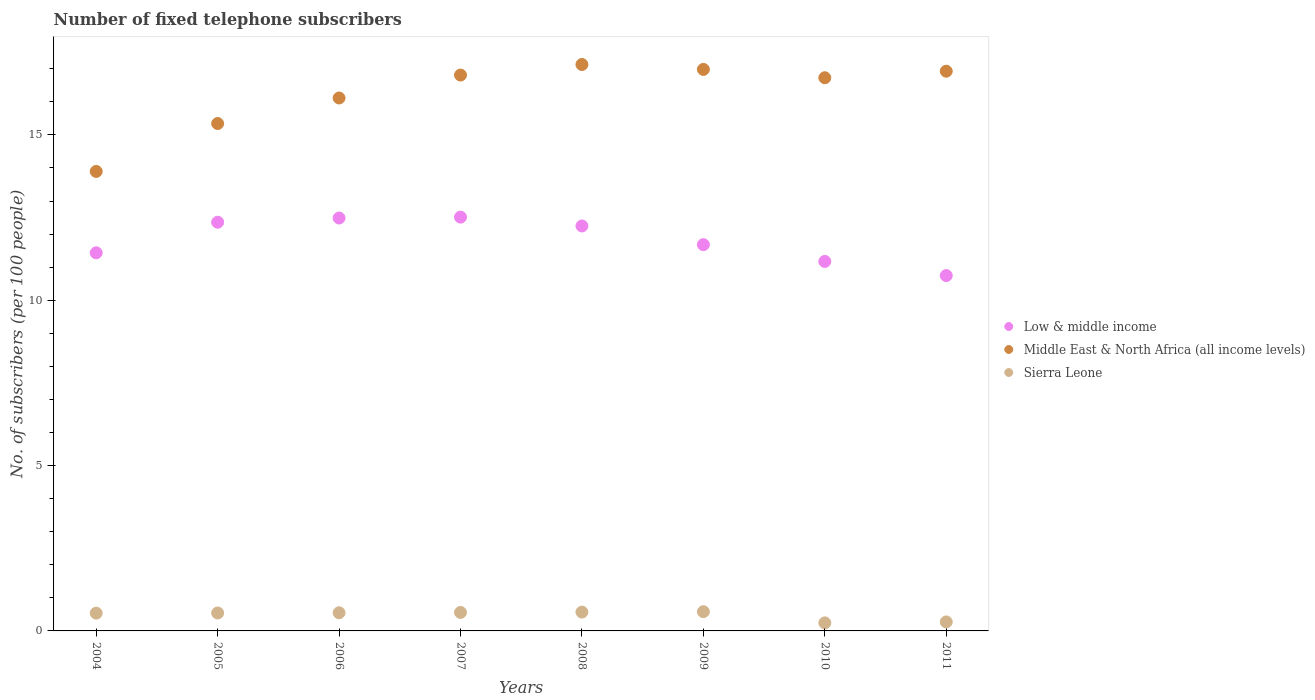How many different coloured dotlines are there?
Your answer should be compact. 3. What is the number of fixed telephone subscribers in Low & middle income in 2007?
Ensure brevity in your answer.  12.51. Across all years, what is the maximum number of fixed telephone subscribers in Low & middle income?
Offer a very short reply. 12.51. Across all years, what is the minimum number of fixed telephone subscribers in Middle East & North Africa (all income levels)?
Offer a terse response. 13.9. What is the total number of fixed telephone subscribers in Middle East & North Africa (all income levels) in the graph?
Offer a very short reply. 129.94. What is the difference between the number of fixed telephone subscribers in Low & middle income in 2008 and that in 2009?
Offer a terse response. 0.57. What is the difference between the number of fixed telephone subscribers in Low & middle income in 2010 and the number of fixed telephone subscribers in Middle East & North Africa (all income levels) in 2007?
Your answer should be very brief. -5.64. What is the average number of fixed telephone subscribers in Middle East & North Africa (all income levels) per year?
Make the answer very short. 16.24. In the year 2009, what is the difference between the number of fixed telephone subscribers in Middle East & North Africa (all income levels) and number of fixed telephone subscribers in Low & middle income?
Keep it short and to the point. 5.3. What is the ratio of the number of fixed telephone subscribers in Low & middle income in 2005 to that in 2009?
Offer a very short reply. 1.06. Is the difference between the number of fixed telephone subscribers in Middle East & North Africa (all income levels) in 2005 and 2011 greater than the difference between the number of fixed telephone subscribers in Low & middle income in 2005 and 2011?
Your response must be concise. No. What is the difference between the highest and the second highest number of fixed telephone subscribers in Sierra Leone?
Keep it short and to the point. 0.01. What is the difference between the highest and the lowest number of fixed telephone subscribers in Low & middle income?
Your answer should be very brief. 1.77. Is it the case that in every year, the sum of the number of fixed telephone subscribers in Low & middle income and number of fixed telephone subscribers in Sierra Leone  is greater than the number of fixed telephone subscribers in Middle East & North Africa (all income levels)?
Make the answer very short. No. Does the number of fixed telephone subscribers in Low & middle income monotonically increase over the years?
Provide a succinct answer. No. Is the number of fixed telephone subscribers in Sierra Leone strictly greater than the number of fixed telephone subscribers in Low & middle income over the years?
Ensure brevity in your answer.  No. How many dotlines are there?
Offer a terse response. 3. What is the difference between two consecutive major ticks on the Y-axis?
Your answer should be compact. 5. Does the graph contain any zero values?
Make the answer very short. No. How are the legend labels stacked?
Make the answer very short. Vertical. What is the title of the graph?
Offer a very short reply. Number of fixed telephone subscribers. What is the label or title of the Y-axis?
Offer a very short reply. No. of subscribers (per 100 people). What is the No. of subscribers (per 100 people) in Low & middle income in 2004?
Offer a very short reply. 11.44. What is the No. of subscribers (per 100 people) of Middle East & North Africa (all income levels) in 2004?
Make the answer very short. 13.9. What is the No. of subscribers (per 100 people) in Sierra Leone in 2004?
Make the answer very short. 0.54. What is the No. of subscribers (per 100 people) of Low & middle income in 2005?
Make the answer very short. 12.36. What is the No. of subscribers (per 100 people) in Middle East & North Africa (all income levels) in 2005?
Provide a succinct answer. 15.34. What is the No. of subscribers (per 100 people) in Sierra Leone in 2005?
Your response must be concise. 0.54. What is the No. of subscribers (per 100 people) of Low & middle income in 2006?
Your answer should be compact. 12.49. What is the No. of subscribers (per 100 people) in Middle East & North Africa (all income levels) in 2006?
Provide a succinct answer. 16.12. What is the No. of subscribers (per 100 people) in Sierra Leone in 2006?
Offer a very short reply. 0.55. What is the No. of subscribers (per 100 people) in Low & middle income in 2007?
Provide a short and direct response. 12.51. What is the No. of subscribers (per 100 people) of Middle East & North Africa (all income levels) in 2007?
Your response must be concise. 16.81. What is the No. of subscribers (per 100 people) of Sierra Leone in 2007?
Make the answer very short. 0.56. What is the No. of subscribers (per 100 people) in Low & middle income in 2008?
Ensure brevity in your answer.  12.25. What is the No. of subscribers (per 100 people) in Middle East & North Africa (all income levels) in 2008?
Give a very brief answer. 17.13. What is the No. of subscribers (per 100 people) in Sierra Leone in 2008?
Your answer should be compact. 0.57. What is the No. of subscribers (per 100 people) in Low & middle income in 2009?
Keep it short and to the point. 11.68. What is the No. of subscribers (per 100 people) in Middle East & North Africa (all income levels) in 2009?
Provide a short and direct response. 16.98. What is the No. of subscribers (per 100 people) in Sierra Leone in 2009?
Provide a short and direct response. 0.58. What is the No. of subscribers (per 100 people) in Low & middle income in 2010?
Provide a short and direct response. 11.17. What is the No. of subscribers (per 100 people) of Middle East & North Africa (all income levels) in 2010?
Offer a very short reply. 16.73. What is the No. of subscribers (per 100 people) in Sierra Leone in 2010?
Your answer should be compact. 0.24. What is the No. of subscribers (per 100 people) in Low & middle income in 2011?
Your response must be concise. 10.75. What is the No. of subscribers (per 100 people) of Middle East & North Africa (all income levels) in 2011?
Offer a very short reply. 16.93. What is the No. of subscribers (per 100 people) of Sierra Leone in 2011?
Offer a very short reply. 0.27. Across all years, what is the maximum No. of subscribers (per 100 people) in Low & middle income?
Provide a short and direct response. 12.51. Across all years, what is the maximum No. of subscribers (per 100 people) in Middle East & North Africa (all income levels)?
Offer a terse response. 17.13. Across all years, what is the maximum No. of subscribers (per 100 people) of Sierra Leone?
Offer a terse response. 0.58. Across all years, what is the minimum No. of subscribers (per 100 people) of Low & middle income?
Keep it short and to the point. 10.75. Across all years, what is the minimum No. of subscribers (per 100 people) of Middle East & North Africa (all income levels)?
Your response must be concise. 13.9. Across all years, what is the minimum No. of subscribers (per 100 people) in Sierra Leone?
Ensure brevity in your answer.  0.24. What is the total No. of subscribers (per 100 people) in Low & middle income in the graph?
Provide a short and direct response. 94.64. What is the total No. of subscribers (per 100 people) of Middle East & North Africa (all income levels) in the graph?
Ensure brevity in your answer.  129.94. What is the total No. of subscribers (per 100 people) in Sierra Leone in the graph?
Offer a terse response. 3.86. What is the difference between the No. of subscribers (per 100 people) of Low & middle income in 2004 and that in 2005?
Your answer should be compact. -0.92. What is the difference between the No. of subscribers (per 100 people) of Middle East & North Africa (all income levels) in 2004 and that in 2005?
Ensure brevity in your answer.  -1.45. What is the difference between the No. of subscribers (per 100 people) in Sierra Leone in 2004 and that in 2005?
Your response must be concise. -0.01. What is the difference between the No. of subscribers (per 100 people) in Low & middle income in 2004 and that in 2006?
Your answer should be very brief. -1.05. What is the difference between the No. of subscribers (per 100 people) of Middle East & North Africa (all income levels) in 2004 and that in 2006?
Offer a terse response. -2.22. What is the difference between the No. of subscribers (per 100 people) of Sierra Leone in 2004 and that in 2006?
Your answer should be very brief. -0.01. What is the difference between the No. of subscribers (per 100 people) in Low & middle income in 2004 and that in 2007?
Offer a terse response. -1.08. What is the difference between the No. of subscribers (per 100 people) in Middle East & North Africa (all income levels) in 2004 and that in 2007?
Make the answer very short. -2.91. What is the difference between the No. of subscribers (per 100 people) of Sierra Leone in 2004 and that in 2007?
Make the answer very short. -0.02. What is the difference between the No. of subscribers (per 100 people) of Low & middle income in 2004 and that in 2008?
Ensure brevity in your answer.  -0.81. What is the difference between the No. of subscribers (per 100 people) in Middle East & North Africa (all income levels) in 2004 and that in 2008?
Your response must be concise. -3.23. What is the difference between the No. of subscribers (per 100 people) in Sierra Leone in 2004 and that in 2008?
Offer a terse response. -0.03. What is the difference between the No. of subscribers (per 100 people) in Low & middle income in 2004 and that in 2009?
Your answer should be very brief. -0.25. What is the difference between the No. of subscribers (per 100 people) in Middle East & North Africa (all income levels) in 2004 and that in 2009?
Provide a succinct answer. -3.09. What is the difference between the No. of subscribers (per 100 people) in Sierra Leone in 2004 and that in 2009?
Keep it short and to the point. -0.04. What is the difference between the No. of subscribers (per 100 people) in Low & middle income in 2004 and that in 2010?
Your answer should be very brief. 0.26. What is the difference between the No. of subscribers (per 100 people) of Middle East & North Africa (all income levels) in 2004 and that in 2010?
Provide a succinct answer. -2.83. What is the difference between the No. of subscribers (per 100 people) of Sierra Leone in 2004 and that in 2010?
Your answer should be very brief. 0.29. What is the difference between the No. of subscribers (per 100 people) in Low & middle income in 2004 and that in 2011?
Your answer should be compact. 0.69. What is the difference between the No. of subscribers (per 100 people) in Middle East & North Africa (all income levels) in 2004 and that in 2011?
Provide a succinct answer. -3.03. What is the difference between the No. of subscribers (per 100 people) of Sierra Leone in 2004 and that in 2011?
Provide a succinct answer. 0.26. What is the difference between the No. of subscribers (per 100 people) in Low & middle income in 2005 and that in 2006?
Offer a terse response. -0.13. What is the difference between the No. of subscribers (per 100 people) in Middle East & North Africa (all income levels) in 2005 and that in 2006?
Provide a short and direct response. -0.77. What is the difference between the No. of subscribers (per 100 people) in Sierra Leone in 2005 and that in 2006?
Offer a very short reply. -0.01. What is the difference between the No. of subscribers (per 100 people) in Low & middle income in 2005 and that in 2007?
Provide a succinct answer. -0.15. What is the difference between the No. of subscribers (per 100 people) in Middle East & North Africa (all income levels) in 2005 and that in 2007?
Your answer should be very brief. -1.47. What is the difference between the No. of subscribers (per 100 people) in Sierra Leone in 2005 and that in 2007?
Provide a succinct answer. -0.02. What is the difference between the No. of subscribers (per 100 people) of Low & middle income in 2005 and that in 2008?
Provide a succinct answer. 0.11. What is the difference between the No. of subscribers (per 100 people) in Middle East & North Africa (all income levels) in 2005 and that in 2008?
Make the answer very short. -1.79. What is the difference between the No. of subscribers (per 100 people) of Sierra Leone in 2005 and that in 2008?
Your answer should be very brief. -0.03. What is the difference between the No. of subscribers (per 100 people) in Low & middle income in 2005 and that in 2009?
Your answer should be very brief. 0.68. What is the difference between the No. of subscribers (per 100 people) of Middle East & North Africa (all income levels) in 2005 and that in 2009?
Give a very brief answer. -1.64. What is the difference between the No. of subscribers (per 100 people) in Sierra Leone in 2005 and that in 2009?
Give a very brief answer. -0.04. What is the difference between the No. of subscribers (per 100 people) in Low & middle income in 2005 and that in 2010?
Offer a terse response. 1.19. What is the difference between the No. of subscribers (per 100 people) in Middle East & North Africa (all income levels) in 2005 and that in 2010?
Your answer should be very brief. -1.38. What is the difference between the No. of subscribers (per 100 people) of Sierra Leone in 2005 and that in 2010?
Offer a very short reply. 0.3. What is the difference between the No. of subscribers (per 100 people) in Low & middle income in 2005 and that in 2011?
Keep it short and to the point. 1.61. What is the difference between the No. of subscribers (per 100 people) in Middle East & North Africa (all income levels) in 2005 and that in 2011?
Keep it short and to the point. -1.58. What is the difference between the No. of subscribers (per 100 people) of Sierra Leone in 2005 and that in 2011?
Your response must be concise. 0.27. What is the difference between the No. of subscribers (per 100 people) in Low & middle income in 2006 and that in 2007?
Give a very brief answer. -0.03. What is the difference between the No. of subscribers (per 100 people) of Middle East & North Africa (all income levels) in 2006 and that in 2007?
Ensure brevity in your answer.  -0.69. What is the difference between the No. of subscribers (per 100 people) of Sierra Leone in 2006 and that in 2007?
Keep it short and to the point. -0.01. What is the difference between the No. of subscribers (per 100 people) of Low & middle income in 2006 and that in 2008?
Ensure brevity in your answer.  0.24. What is the difference between the No. of subscribers (per 100 people) in Middle East & North Africa (all income levels) in 2006 and that in 2008?
Your answer should be compact. -1.01. What is the difference between the No. of subscribers (per 100 people) of Sierra Leone in 2006 and that in 2008?
Offer a very short reply. -0.02. What is the difference between the No. of subscribers (per 100 people) in Low & middle income in 2006 and that in 2009?
Give a very brief answer. 0.81. What is the difference between the No. of subscribers (per 100 people) in Middle East & North Africa (all income levels) in 2006 and that in 2009?
Your response must be concise. -0.86. What is the difference between the No. of subscribers (per 100 people) in Sierra Leone in 2006 and that in 2009?
Ensure brevity in your answer.  -0.03. What is the difference between the No. of subscribers (per 100 people) of Low & middle income in 2006 and that in 2010?
Provide a succinct answer. 1.31. What is the difference between the No. of subscribers (per 100 people) of Middle East & North Africa (all income levels) in 2006 and that in 2010?
Your answer should be compact. -0.61. What is the difference between the No. of subscribers (per 100 people) of Sierra Leone in 2006 and that in 2010?
Give a very brief answer. 0.31. What is the difference between the No. of subscribers (per 100 people) in Low & middle income in 2006 and that in 2011?
Your answer should be very brief. 1.74. What is the difference between the No. of subscribers (per 100 people) of Middle East & North Africa (all income levels) in 2006 and that in 2011?
Your answer should be compact. -0.81. What is the difference between the No. of subscribers (per 100 people) in Sierra Leone in 2006 and that in 2011?
Keep it short and to the point. 0.28. What is the difference between the No. of subscribers (per 100 people) in Low & middle income in 2007 and that in 2008?
Ensure brevity in your answer.  0.27. What is the difference between the No. of subscribers (per 100 people) in Middle East & North Africa (all income levels) in 2007 and that in 2008?
Offer a very short reply. -0.32. What is the difference between the No. of subscribers (per 100 people) in Sierra Leone in 2007 and that in 2008?
Ensure brevity in your answer.  -0.01. What is the difference between the No. of subscribers (per 100 people) in Low & middle income in 2007 and that in 2009?
Ensure brevity in your answer.  0.83. What is the difference between the No. of subscribers (per 100 people) in Middle East & North Africa (all income levels) in 2007 and that in 2009?
Keep it short and to the point. -0.17. What is the difference between the No. of subscribers (per 100 people) in Sierra Leone in 2007 and that in 2009?
Your answer should be very brief. -0.02. What is the difference between the No. of subscribers (per 100 people) of Low & middle income in 2007 and that in 2010?
Provide a short and direct response. 1.34. What is the difference between the No. of subscribers (per 100 people) in Middle East & North Africa (all income levels) in 2007 and that in 2010?
Your answer should be compact. 0.08. What is the difference between the No. of subscribers (per 100 people) of Sierra Leone in 2007 and that in 2010?
Offer a very short reply. 0.32. What is the difference between the No. of subscribers (per 100 people) of Low & middle income in 2007 and that in 2011?
Offer a terse response. 1.77. What is the difference between the No. of subscribers (per 100 people) in Middle East & North Africa (all income levels) in 2007 and that in 2011?
Your answer should be very brief. -0.12. What is the difference between the No. of subscribers (per 100 people) of Sierra Leone in 2007 and that in 2011?
Make the answer very short. 0.29. What is the difference between the No. of subscribers (per 100 people) of Low & middle income in 2008 and that in 2009?
Your answer should be compact. 0.57. What is the difference between the No. of subscribers (per 100 people) of Middle East & North Africa (all income levels) in 2008 and that in 2009?
Provide a short and direct response. 0.15. What is the difference between the No. of subscribers (per 100 people) of Sierra Leone in 2008 and that in 2009?
Your response must be concise. -0.01. What is the difference between the No. of subscribers (per 100 people) of Low & middle income in 2008 and that in 2010?
Provide a short and direct response. 1.07. What is the difference between the No. of subscribers (per 100 people) in Middle East & North Africa (all income levels) in 2008 and that in 2010?
Keep it short and to the point. 0.4. What is the difference between the No. of subscribers (per 100 people) in Sierra Leone in 2008 and that in 2010?
Your answer should be very brief. 0.33. What is the difference between the No. of subscribers (per 100 people) of Low & middle income in 2008 and that in 2011?
Provide a succinct answer. 1.5. What is the difference between the No. of subscribers (per 100 people) of Middle East & North Africa (all income levels) in 2008 and that in 2011?
Make the answer very short. 0.2. What is the difference between the No. of subscribers (per 100 people) in Sierra Leone in 2008 and that in 2011?
Provide a succinct answer. 0.3. What is the difference between the No. of subscribers (per 100 people) in Low & middle income in 2009 and that in 2010?
Ensure brevity in your answer.  0.51. What is the difference between the No. of subscribers (per 100 people) in Middle East & North Africa (all income levels) in 2009 and that in 2010?
Your response must be concise. 0.25. What is the difference between the No. of subscribers (per 100 people) in Sierra Leone in 2009 and that in 2010?
Provide a succinct answer. 0.34. What is the difference between the No. of subscribers (per 100 people) of Low & middle income in 2009 and that in 2011?
Your answer should be very brief. 0.93. What is the difference between the No. of subscribers (per 100 people) in Middle East & North Africa (all income levels) in 2009 and that in 2011?
Your answer should be compact. 0.05. What is the difference between the No. of subscribers (per 100 people) of Sierra Leone in 2009 and that in 2011?
Your answer should be very brief. 0.31. What is the difference between the No. of subscribers (per 100 people) of Low & middle income in 2010 and that in 2011?
Your answer should be compact. 0.43. What is the difference between the No. of subscribers (per 100 people) in Middle East & North Africa (all income levels) in 2010 and that in 2011?
Make the answer very short. -0.2. What is the difference between the No. of subscribers (per 100 people) of Sierra Leone in 2010 and that in 2011?
Ensure brevity in your answer.  -0.03. What is the difference between the No. of subscribers (per 100 people) of Low & middle income in 2004 and the No. of subscribers (per 100 people) of Middle East & North Africa (all income levels) in 2005?
Keep it short and to the point. -3.91. What is the difference between the No. of subscribers (per 100 people) of Low & middle income in 2004 and the No. of subscribers (per 100 people) of Sierra Leone in 2005?
Your response must be concise. 10.89. What is the difference between the No. of subscribers (per 100 people) in Middle East & North Africa (all income levels) in 2004 and the No. of subscribers (per 100 people) in Sierra Leone in 2005?
Offer a terse response. 13.35. What is the difference between the No. of subscribers (per 100 people) in Low & middle income in 2004 and the No. of subscribers (per 100 people) in Middle East & North Africa (all income levels) in 2006?
Ensure brevity in your answer.  -4.68. What is the difference between the No. of subscribers (per 100 people) in Low & middle income in 2004 and the No. of subscribers (per 100 people) in Sierra Leone in 2006?
Ensure brevity in your answer.  10.89. What is the difference between the No. of subscribers (per 100 people) in Middle East & North Africa (all income levels) in 2004 and the No. of subscribers (per 100 people) in Sierra Leone in 2006?
Provide a short and direct response. 13.35. What is the difference between the No. of subscribers (per 100 people) of Low & middle income in 2004 and the No. of subscribers (per 100 people) of Middle East & North Africa (all income levels) in 2007?
Offer a very short reply. -5.38. What is the difference between the No. of subscribers (per 100 people) of Low & middle income in 2004 and the No. of subscribers (per 100 people) of Sierra Leone in 2007?
Provide a succinct answer. 10.88. What is the difference between the No. of subscribers (per 100 people) of Middle East & North Africa (all income levels) in 2004 and the No. of subscribers (per 100 people) of Sierra Leone in 2007?
Offer a very short reply. 13.34. What is the difference between the No. of subscribers (per 100 people) of Low & middle income in 2004 and the No. of subscribers (per 100 people) of Middle East & North Africa (all income levels) in 2008?
Keep it short and to the point. -5.69. What is the difference between the No. of subscribers (per 100 people) in Low & middle income in 2004 and the No. of subscribers (per 100 people) in Sierra Leone in 2008?
Make the answer very short. 10.87. What is the difference between the No. of subscribers (per 100 people) of Middle East & North Africa (all income levels) in 2004 and the No. of subscribers (per 100 people) of Sierra Leone in 2008?
Give a very brief answer. 13.33. What is the difference between the No. of subscribers (per 100 people) of Low & middle income in 2004 and the No. of subscribers (per 100 people) of Middle East & North Africa (all income levels) in 2009?
Your answer should be compact. -5.55. What is the difference between the No. of subscribers (per 100 people) of Low & middle income in 2004 and the No. of subscribers (per 100 people) of Sierra Leone in 2009?
Your answer should be compact. 10.85. What is the difference between the No. of subscribers (per 100 people) of Middle East & North Africa (all income levels) in 2004 and the No. of subscribers (per 100 people) of Sierra Leone in 2009?
Offer a very short reply. 13.31. What is the difference between the No. of subscribers (per 100 people) in Low & middle income in 2004 and the No. of subscribers (per 100 people) in Middle East & North Africa (all income levels) in 2010?
Offer a very short reply. -5.29. What is the difference between the No. of subscribers (per 100 people) of Low & middle income in 2004 and the No. of subscribers (per 100 people) of Sierra Leone in 2010?
Keep it short and to the point. 11.19. What is the difference between the No. of subscribers (per 100 people) in Middle East & North Africa (all income levels) in 2004 and the No. of subscribers (per 100 people) in Sierra Leone in 2010?
Keep it short and to the point. 13.65. What is the difference between the No. of subscribers (per 100 people) of Low & middle income in 2004 and the No. of subscribers (per 100 people) of Middle East & North Africa (all income levels) in 2011?
Provide a short and direct response. -5.49. What is the difference between the No. of subscribers (per 100 people) in Low & middle income in 2004 and the No. of subscribers (per 100 people) in Sierra Leone in 2011?
Offer a very short reply. 11.16. What is the difference between the No. of subscribers (per 100 people) of Middle East & North Africa (all income levels) in 2004 and the No. of subscribers (per 100 people) of Sierra Leone in 2011?
Give a very brief answer. 13.62. What is the difference between the No. of subscribers (per 100 people) in Low & middle income in 2005 and the No. of subscribers (per 100 people) in Middle East & North Africa (all income levels) in 2006?
Provide a short and direct response. -3.76. What is the difference between the No. of subscribers (per 100 people) of Low & middle income in 2005 and the No. of subscribers (per 100 people) of Sierra Leone in 2006?
Your answer should be compact. 11.81. What is the difference between the No. of subscribers (per 100 people) in Middle East & North Africa (all income levels) in 2005 and the No. of subscribers (per 100 people) in Sierra Leone in 2006?
Your answer should be very brief. 14.8. What is the difference between the No. of subscribers (per 100 people) of Low & middle income in 2005 and the No. of subscribers (per 100 people) of Middle East & North Africa (all income levels) in 2007?
Your answer should be compact. -4.45. What is the difference between the No. of subscribers (per 100 people) of Low & middle income in 2005 and the No. of subscribers (per 100 people) of Sierra Leone in 2007?
Offer a very short reply. 11.8. What is the difference between the No. of subscribers (per 100 people) of Middle East & North Africa (all income levels) in 2005 and the No. of subscribers (per 100 people) of Sierra Leone in 2007?
Your response must be concise. 14.79. What is the difference between the No. of subscribers (per 100 people) of Low & middle income in 2005 and the No. of subscribers (per 100 people) of Middle East & North Africa (all income levels) in 2008?
Keep it short and to the point. -4.77. What is the difference between the No. of subscribers (per 100 people) in Low & middle income in 2005 and the No. of subscribers (per 100 people) in Sierra Leone in 2008?
Offer a terse response. 11.79. What is the difference between the No. of subscribers (per 100 people) in Middle East & North Africa (all income levels) in 2005 and the No. of subscribers (per 100 people) in Sierra Leone in 2008?
Offer a terse response. 14.78. What is the difference between the No. of subscribers (per 100 people) of Low & middle income in 2005 and the No. of subscribers (per 100 people) of Middle East & North Africa (all income levels) in 2009?
Provide a succinct answer. -4.62. What is the difference between the No. of subscribers (per 100 people) of Low & middle income in 2005 and the No. of subscribers (per 100 people) of Sierra Leone in 2009?
Your answer should be compact. 11.78. What is the difference between the No. of subscribers (per 100 people) in Middle East & North Africa (all income levels) in 2005 and the No. of subscribers (per 100 people) in Sierra Leone in 2009?
Provide a short and direct response. 14.76. What is the difference between the No. of subscribers (per 100 people) of Low & middle income in 2005 and the No. of subscribers (per 100 people) of Middle East & North Africa (all income levels) in 2010?
Provide a succinct answer. -4.37. What is the difference between the No. of subscribers (per 100 people) in Low & middle income in 2005 and the No. of subscribers (per 100 people) in Sierra Leone in 2010?
Provide a succinct answer. 12.12. What is the difference between the No. of subscribers (per 100 people) of Middle East & North Africa (all income levels) in 2005 and the No. of subscribers (per 100 people) of Sierra Leone in 2010?
Make the answer very short. 15.1. What is the difference between the No. of subscribers (per 100 people) in Low & middle income in 2005 and the No. of subscribers (per 100 people) in Middle East & North Africa (all income levels) in 2011?
Provide a short and direct response. -4.57. What is the difference between the No. of subscribers (per 100 people) of Low & middle income in 2005 and the No. of subscribers (per 100 people) of Sierra Leone in 2011?
Give a very brief answer. 12.09. What is the difference between the No. of subscribers (per 100 people) in Middle East & North Africa (all income levels) in 2005 and the No. of subscribers (per 100 people) in Sierra Leone in 2011?
Your answer should be very brief. 15.07. What is the difference between the No. of subscribers (per 100 people) of Low & middle income in 2006 and the No. of subscribers (per 100 people) of Middle East & North Africa (all income levels) in 2007?
Keep it short and to the point. -4.32. What is the difference between the No. of subscribers (per 100 people) in Low & middle income in 2006 and the No. of subscribers (per 100 people) in Sierra Leone in 2007?
Offer a very short reply. 11.93. What is the difference between the No. of subscribers (per 100 people) in Middle East & North Africa (all income levels) in 2006 and the No. of subscribers (per 100 people) in Sierra Leone in 2007?
Provide a succinct answer. 15.56. What is the difference between the No. of subscribers (per 100 people) of Low & middle income in 2006 and the No. of subscribers (per 100 people) of Middle East & North Africa (all income levels) in 2008?
Offer a terse response. -4.64. What is the difference between the No. of subscribers (per 100 people) in Low & middle income in 2006 and the No. of subscribers (per 100 people) in Sierra Leone in 2008?
Ensure brevity in your answer.  11.92. What is the difference between the No. of subscribers (per 100 people) of Middle East & North Africa (all income levels) in 2006 and the No. of subscribers (per 100 people) of Sierra Leone in 2008?
Offer a very short reply. 15.55. What is the difference between the No. of subscribers (per 100 people) of Low & middle income in 2006 and the No. of subscribers (per 100 people) of Middle East & North Africa (all income levels) in 2009?
Give a very brief answer. -4.49. What is the difference between the No. of subscribers (per 100 people) in Low & middle income in 2006 and the No. of subscribers (per 100 people) in Sierra Leone in 2009?
Provide a short and direct response. 11.91. What is the difference between the No. of subscribers (per 100 people) in Middle East & North Africa (all income levels) in 2006 and the No. of subscribers (per 100 people) in Sierra Leone in 2009?
Provide a short and direct response. 15.54. What is the difference between the No. of subscribers (per 100 people) in Low & middle income in 2006 and the No. of subscribers (per 100 people) in Middle East & North Africa (all income levels) in 2010?
Your response must be concise. -4.24. What is the difference between the No. of subscribers (per 100 people) of Low & middle income in 2006 and the No. of subscribers (per 100 people) of Sierra Leone in 2010?
Make the answer very short. 12.24. What is the difference between the No. of subscribers (per 100 people) in Middle East & North Africa (all income levels) in 2006 and the No. of subscribers (per 100 people) in Sierra Leone in 2010?
Provide a succinct answer. 15.87. What is the difference between the No. of subscribers (per 100 people) of Low & middle income in 2006 and the No. of subscribers (per 100 people) of Middle East & North Africa (all income levels) in 2011?
Offer a very short reply. -4.44. What is the difference between the No. of subscribers (per 100 people) of Low & middle income in 2006 and the No. of subscribers (per 100 people) of Sierra Leone in 2011?
Offer a very short reply. 12.21. What is the difference between the No. of subscribers (per 100 people) in Middle East & North Africa (all income levels) in 2006 and the No. of subscribers (per 100 people) in Sierra Leone in 2011?
Provide a short and direct response. 15.84. What is the difference between the No. of subscribers (per 100 people) in Low & middle income in 2007 and the No. of subscribers (per 100 people) in Middle East & North Africa (all income levels) in 2008?
Offer a very short reply. -4.62. What is the difference between the No. of subscribers (per 100 people) in Low & middle income in 2007 and the No. of subscribers (per 100 people) in Sierra Leone in 2008?
Ensure brevity in your answer.  11.94. What is the difference between the No. of subscribers (per 100 people) in Middle East & North Africa (all income levels) in 2007 and the No. of subscribers (per 100 people) in Sierra Leone in 2008?
Provide a succinct answer. 16.24. What is the difference between the No. of subscribers (per 100 people) in Low & middle income in 2007 and the No. of subscribers (per 100 people) in Middle East & North Africa (all income levels) in 2009?
Your answer should be very brief. -4.47. What is the difference between the No. of subscribers (per 100 people) in Low & middle income in 2007 and the No. of subscribers (per 100 people) in Sierra Leone in 2009?
Make the answer very short. 11.93. What is the difference between the No. of subscribers (per 100 people) in Middle East & North Africa (all income levels) in 2007 and the No. of subscribers (per 100 people) in Sierra Leone in 2009?
Offer a very short reply. 16.23. What is the difference between the No. of subscribers (per 100 people) in Low & middle income in 2007 and the No. of subscribers (per 100 people) in Middle East & North Africa (all income levels) in 2010?
Offer a terse response. -4.21. What is the difference between the No. of subscribers (per 100 people) of Low & middle income in 2007 and the No. of subscribers (per 100 people) of Sierra Leone in 2010?
Provide a succinct answer. 12.27. What is the difference between the No. of subscribers (per 100 people) in Middle East & North Africa (all income levels) in 2007 and the No. of subscribers (per 100 people) in Sierra Leone in 2010?
Your answer should be very brief. 16.57. What is the difference between the No. of subscribers (per 100 people) in Low & middle income in 2007 and the No. of subscribers (per 100 people) in Middle East & North Africa (all income levels) in 2011?
Ensure brevity in your answer.  -4.41. What is the difference between the No. of subscribers (per 100 people) in Low & middle income in 2007 and the No. of subscribers (per 100 people) in Sierra Leone in 2011?
Your answer should be compact. 12.24. What is the difference between the No. of subscribers (per 100 people) of Middle East & North Africa (all income levels) in 2007 and the No. of subscribers (per 100 people) of Sierra Leone in 2011?
Give a very brief answer. 16.54. What is the difference between the No. of subscribers (per 100 people) of Low & middle income in 2008 and the No. of subscribers (per 100 people) of Middle East & North Africa (all income levels) in 2009?
Keep it short and to the point. -4.73. What is the difference between the No. of subscribers (per 100 people) in Low & middle income in 2008 and the No. of subscribers (per 100 people) in Sierra Leone in 2009?
Ensure brevity in your answer.  11.67. What is the difference between the No. of subscribers (per 100 people) of Middle East & North Africa (all income levels) in 2008 and the No. of subscribers (per 100 people) of Sierra Leone in 2009?
Your response must be concise. 16.55. What is the difference between the No. of subscribers (per 100 people) in Low & middle income in 2008 and the No. of subscribers (per 100 people) in Middle East & North Africa (all income levels) in 2010?
Give a very brief answer. -4.48. What is the difference between the No. of subscribers (per 100 people) of Low & middle income in 2008 and the No. of subscribers (per 100 people) of Sierra Leone in 2010?
Your answer should be compact. 12. What is the difference between the No. of subscribers (per 100 people) of Middle East & North Africa (all income levels) in 2008 and the No. of subscribers (per 100 people) of Sierra Leone in 2010?
Your answer should be compact. 16.89. What is the difference between the No. of subscribers (per 100 people) of Low & middle income in 2008 and the No. of subscribers (per 100 people) of Middle East & North Africa (all income levels) in 2011?
Offer a very short reply. -4.68. What is the difference between the No. of subscribers (per 100 people) in Low & middle income in 2008 and the No. of subscribers (per 100 people) in Sierra Leone in 2011?
Your answer should be very brief. 11.97. What is the difference between the No. of subscribers (per 100 people) in Middle East & North Africa (all income levels) in 2008 and the No. of subscribers (per 100 people) in Sierra Leone in 2011?
Your answer should be very brief. 16.86. What is the difference between the No. of subscribers (per 100 people) in Low & middle income in 2009 and the No. of subscribers (per 100 people) in Middle East & North Africa (all income levels) in 2010?
Ensure brevity in your answer.  -5.05. What is the difference between the No. of subscribers (per 100 people) in Low & middle income in 2009 and the No. of subscribers (per 100 people) in Sierra Leone in 2010?
Make the answer very short. 11.44. What is the difference between the No. of subscribers (per 100 people) in Middle East & North Africa (all income levels) in 2009 and the No. of subscribers (per 100 people) in Sierra Leone in 2010?
Your answer should be very brief. 16.74. What is the difference between the No. of subscribers (per 100 people) in Low & middle income in 2009 and the No. of subscribers (per 100 people) in Middle East & North Africa (all income levels) in 2011?
Provide a succinct answer. -5.25. What is the difference between the No. of subscribers (per 100 people) in Low & middle income in 2009 and the No. of subscribers (per 100 people) in Sierra Leone in 2011?
Give a very brief answer. 11.41. What is the difference between the No. of subscribers (per 100 people) of Middle East & North Africa (all income levels) in 2009 and the No. of subscribers (per 100 people) of Sierra Leone in 2011?
Give a very brief answer. 16.71. What is the difference between the No. of subscribers (per 100 people) of Low & middle income in 2010 and the No. of subscribers (per 100 people) of Middle East & North Africa (all income levels) in 2011?
Make the answer very short. -5.75. What is the difference between the No. of subscribers (per 100 people) of Low & middle income in 2010 and the No. of subscribers (per 100 people) of Sierra Leone in 2011?
Offer a very short reply. 10.9. What is the difference between the No. of subscribers (per 100 people) of Middle East & North Africa (all income levels) in 2010 and the No. of subscribers (per 100 people) of Sierra Leone in 2011?
Offer a terse response. 16.46. What is the average No. of subscribers (per 100 people) of Low & middle income per year?
Offer a very short reply. 11.83. What is the average No. of subscribers (per 100 people) of Middle East & North Africa (all income levels) per year?
Your answer should be very brief. 16.24. What is the average No. of subscribers (per 100 people) of Sierra Leone per year?
Provide a succinct answer. 0.48. In the year 2004, what is the difference between the No. of subscribers (per 100 people) in Low & middle income and No. of subscribers (per 100 people) in Middle East & North Africa (all income levels)?
Your response must be concise. -2.46. In the year 2004, what is the difference between the No. of subscribers (per 100 people) of Low & middle income and No. of subscribers (per 100 people) of Sierra Leone?
Keep it short and to the point. 10.9. In the year 2004, what is the difference between the No. of subscribers (per 100 people) of Middle East & North Africa (all income levels) and No. of subscribers (per 100 people) of Sierra Leone?
Make the answer very short. 13.36. In the year 2005, what is the difference between the No. of subscribers (per 100 people) of Low & middle income and No. of subscribers (per 100 people) of Middle East & North Africa (all income levels)?
Make the answer very short. -2.98. In the year 2005, what is the difference between the No. of subscribers (per 100 people) in Low & middle income and No. of subscribers (per 100 people) in Sierra Leone?
Your answer should be compact. 11.82. In the year 2005, what is the difference between the No. of subscribers (per 100 people) in Middle East & North Africa (all income levels) and No. of subscribers (per 100 people) in Sierra Leone?
Keep it short and to the point. 14.8. In the year 2006, what is the difference between the No. of subscribers (per 100 people) in Low & middle income and No. of subscribers (per 100 people) in Middle East & North Africa (all income levels)?
Give a very brief answer. -3.63. In the year 2006, what is the difference between the No. of subscribers (per 100 people) of Low & middle income and No. of subscribers (per 100 people) of Sierra Leone?
Your response must be concise. 11.94. In the year 2006, what is the difference between the No. of subscribers (per 100 people) of Middle East & North Africa (all income levels) and No. of subscribers (per 100 people) of Sierra Leone?
Your answer should be compact. 15.57. In the year 2007, what is the difference between the No. of subscribers (per 100 people) in Low & middle income and No. of subscribers (per 100 people) in Middle East & North Africa (all income levels)?
Make the answer very short. -4.3. In the year 2007, what is the difference between the No. of subscribers (per 100 people) of Low & middle income and No. of subscribers (per 100 people) of Sierra Leone?
Make the answer very short. 11.95. In the year 2007, what is the difference between the No. of subscribers (per 100 people) in Middle East & North Africa (all income levels) and No. of subscribers (per 100 people) in Sierra Leone?
Your answer should be compact. 16.25. In the year 2008, what is the difference between the No. of subscribers (per 100 people) in Low & middle income and No. of subscribers (per 100 people) in Middle East & North Africa (all income levels)?
Your response must be concise. -4.88. In the year 2008, what is the difference between the No. of subscribers (per 100 people) in Low & middle income and No. of subscribers (per 100 people) in Sierra Leone?
Ensure brevity in your answer.  11.68. In the year 2008, what is the difference between the No. of subscribers (per 100 people) of Middle East & North Africa (all income levels) and No. of subscribers (per 100 people) of Sierra Leone?
Give a very brief answer. 16.56. In the year 2009, what is the difference between the No. of subscribers (per 100 people) of Low & middle income and No. of subscribers (per 100 people) of Middle East & North Africa (all income levels)?
Provide a short and direct response. -5.3. In the year 2009, what is the difference between the No. of subscribers (per 100 people) of Low & middle income and No. of subscribers (per 100 people) of Sierra Leone?
Offer a terse response. 11.1. In the year 2009, what is the difference between the No. of subscribers (per 100 people) of Middle East & North Africa (all income levels) and No. of subscribers (per 100 people) of Sierra Leone?
Provide a succinct answer. 16.4. In the year 2010, what is the difference between the No. of subscribers (per 100 people) of Low & middle income and No. of subscribers (per 100 people) of Middle East & North Africa (all income levels)?
Offer a very short reply. -5.56. In the year 2010, what is the difference between the No. of subscribers (per 100 people) in Low & middle income and No. of subscribers (per 100 people) in Sierra Leone?
Your answer should be compact. 10.93. In the year 2010, what is the difference between the No. of subscribers (per 100 people) of Middle East & North Africa (all income levels) and No. of subscribers (per 100 people) of Sierra Leone?
Your answer should be compact. 16.49. In the year 2011, what is the difference between the No. of subscribers (per 100 people) in Low & middle income and No. of subscribers (per 100 people) in Middle East & North Africa (all income levels)?
Offer a terse response. -6.18. In the year 2011, what is the difference between the No. of subscribers (per 100 people) of Low & middle income and No. of subscribers (per 100 people) of Sierra Leone?
Ensure brevity in your answer.  10.47. In the year 2011, what is the difference between the No. of subscribers (per 100 people) of Middle East & North Africa (all income levels) and No. of subscribers (per 100 people) of Sierra Leone?
Ensure brevity in your answer.  16.65. What is the ratio of the No. of subscribers (per 100 people) in Low & middle income in 2004 to that in 2005?
Provide a short and direct response. 0.93. What is the ratio of the No. of subscribers (per 100 people) in Middle East & North Africa (all income levels) in 2004 to that in 2005?
Your response must be concise. 0.91. What is the ratio of the No. of subscribers (per 100 people) of Sierra Leone in 2004 to that in 2005?
Give a very brief answer. 0.99. What is the ratio of the No. of subscribers (per 100 people) in Low & middle income in 2004 to that in 2006?
Give a very brief answer. 0.92. What is the ratio of the No. of subscribers (per 100 people) of Middle East & North Africa (all income levels) in 2004 to that in 2006?
Provide a succinct answer. 0.86. What is the ratio of the No. of subscribers (per 100 people) in Sierra Leone in 2004 to that in 2006?
Your answer should be compact. 0.98. What is the ratio of the No. of subscribers (per 100 people) in Low & middle income in 2004 to that in 2007?
Make the answer very short. 0.91. What is the ratio of the No. of subscribers (per 100 people) in Middle East & North Africa (all income levels) in 2004 to that in 2007?
Make the answer very short. 0.83. What is the ratio of the No. of subscribers (per 100 people) in Sierra Leone in 2004 to that in 2007?
Your answer should be compact. 0.96. What is the ratio of the No. of subscribers (per 100 people) of Low & middle income in 2004 to that in 2008?
Give a very brief answer. 0.93. What is the ratio of the No. of subscribers (per 100 people) of Middle East & North Africa (all income levels) in 2004 to that in 2008?
Your answer should be compact. 0.81. What is the ratio of the No. of subscribers (per 100 people) of Sierra Leone in 2004 to that in 2008?
Your response must be concise. 0.94. What is the ratio of the No. of subscribers (per 100 people) in Middle East & North Africa (all income levels) in 2004 to that in 2009?
Your answer should be very brief. 0.82. What is the ratio of the No. of subscribers (per 100 people) in Sierra Leone in 2004 to that in 2009?
Ensure brevity in your answer.  0.92. What is the ratio of the No. of subscribers (per 100 people) of Low & middle income in 2004 to that in 2010?
Give a very brief answer. 1.02. What is the ratio of the No. of subscribers (per 100 people) of Middle East & North Africa (all income levels) in 2004 to that in 2010?
Give a very brief answer. 0.83. What is the ratio of the No. of subscribers (per 100 people) of Sierra Leone in 2004 to that in 2010?
Keep it short and to the point. 2.21. What is the ratio of the No. of subscribers (per 100 people) in Low & middle income in 2004 to that in 2011?
Ensure brevity in your answer.  1.06. What is the ratio of the No. of subscribers (per 100 people) of Middle East & North Africa (all income levels) in 2004 to that in 2011?
Make the answer very short. 0.82. What is the ratio of the No. of subscribers (per 100 people) of Sierra Leone in 2004 to that in 2011?
Your answer should be compact. 1.97. What is the ratio of the No. of subscribers (per 100 people) in Low & middle income in 2005 to that in 2006?
Offer a terse response. 0.99. What is the ratio of the No. of subscribers (per 100 people) in Middle East & North Africa (all income levels) in 2005 to that in 2006?
Your answer should be compact. 0.95. What is the ratio of the No. of subscribers (per 100 people) of Sierra Leone in 2005 to that in 2006?
Give a very brief answer. 0.99. What is the ratio of the No. of subscribers (per 100 people) in Low & middle income in 2005 to that in 2007?
Provide a short and direct response. 0.99. What is the ratio of the No. of subscribers (per 100 people) of Middle East & North Africa (all income levels) in 2005 to that in 2007?
Provide a succinct answer. 0.91. What is the ratio of the No. of subscribers (per 100 people) in Sierra Leone in 2005 to that in 2007?
Ensure brevity in your answer.  0.97. What is the ratio of the No. of subscribers (per 100 people) of Low & middle income in 2005 to that in 2008?
Provide a succinct answer. 1.01. What is the ratio of the No. of subscribers (per 100 people) of Middle East & North Africa (all income levels) in 2005 to that in 2008?
Your answer should be compact. 0.9. What is the ratio of the No. of subscribers (per 100 people) of Sierra Leone in 2005 to that in 2008?
Provide a short and direct response. 0.95. What is the ratio of the No. of subscribers (per 100 people) of Low & middle income in 2005 to that in 2009?
Offer a very short reply. 1.06. What is the ratio of the No. of subscribers (per 100 people) of Middle East & North Africa (all income levels) in 2005 to that in 2009?
Keep it short and to the point. 0.9. What is the ratio of the No. of subscribers (per 100 people) in Sierra Leone in 2005 to that in 2009?
Keep it short and to the point. 0.93. What is the ratio of the No. of subscribers (per 100 people) in Low & middle income in 2005 to that in 2010?
Provide a short and direct response. 1.11. What is the ratio of the No. of subscribers (per 100 people) of Middle East & North Africa (all income levels) in 2005 to that in 2010?
Offer a very short reply. 0.92. What is the ratio of the No. of subscribers (per 100 people) of Sierra Leone in 2005 to that in 2010?
Your response must be concise. 2.23. What is the ratio of the No. of subscribers (per 100 people) of Low & middle income in 2005 to that in 2011?
Provide a succinct answer. 1.15. What is the ratio of the No. of subscribers (per 100 people) of Middle East & North Africa (all income levels) in 2005 to that in 2011?
Ensure brevity in your answer.  0.91. What is the ratio of the No. of subscribers (per 100 people) of Sierra Leone in 2005 to that in 2011?
Offer a terse response. 1.99. What is the ratio of the No. of subscribers (per 100 people) in Low & middle income in 2006 to that in 2007?
Your answer should be compact. 1. What is the ratio of the No. of subscribers (per 100 people) in Middle East & North Africa (all income levels) in 2006 to that in 2007?
Offer a terse response. 0.96. What is the ratio of the No. of subscribers (per 100 people) in Sierra Leone in 2006 to that in 2007?
Keep it short and to the point. 0.98. What is the ratio of the No. of subscribers (per 100 people) in Low & middle income in 2006 to that in 2008?
Your answer should be very brief. 1.02. What is the ratio of the No. of subscribers (per 100 people) of Middle East & North Africa (all income levels) in 2006 to that in 2008?
Your answer should be very brief. 0.94. What is the ratio of the No. of subscribers (per 100 people) of Sierra Leone in 2006 to that in 2008?
Your answer should be compact. 0.96. What is the ratio of the No. of subscribers (per 100 people) in Low & middle income in 2006 to that in 2009?
Keep it short and to the point. 1.07. What is the ratio of the No. of subscribers (per 100 people) in Middle East & North Africa (all income levels) in 2006 to that in 2009?
Keep it short and to the point. 0.95. What is the ratio of the No. of subscribers (per 100 people) in Sierra Leone in 2006 to that in 2009?
Offer a very short reply. 0.94. What is the ratio of the No. of subscribers (per 100 people) of Low & middle income in 2006 to that in 2010?
Provide a succinct answer. 1.12. What is the ratio of the No. of subscribers (per 100 people) in Middle East & North Africa (all income levels) in 2006 to that in 2010?
Offer a very short reply. 0.96. What is the ratio of the No. of subscribers (per 100 people) of Sierra Leone in 2006 to that in 2010?
Give a very brief answer. 2.26. What is the ratio of the No. of subscribers (per 100 people) in Low & middle income in 2006 to that in 2011?
Offer a very short reply. 1.16. What is the ratio of the No. of subscribers (per 100 people) in Middle East & North Africa (all income levels) in 2006 to that in 2011?
Give a very brief answer. 0.95. What is the ratio of the No. of subscribers (per 100 people) of Sierra Leone in 2006 to that in 2011?
Your answer should be compact. 2.01. What is the ratio of the No. of subscribers (per 100 people) of Low & middle income in 2007 to that in 2008?
Make the answer very short. 1.02. What is the ratio of the No. of subscribers (per 100 people) of Middle East & North Africa (all income levels) in 2007 to that in 2008?
Provide a succinct answer. 0.98. What is the ratio of the No. of subscribers (per 100 people) in Sierra Leone in 2007 to that in 2008?
Make the answer very short. 0.98. What is the ratio of the No. of subscribers (per 100 people) in Low & middle income in 2007 to that in 2009?
Provide a succinct answer. 1.07. What is the ratio of the No. of subscribers (per 100 people) in Sierra Leone in 2007 to that in 2009?
Your response must be concise. 0.96. What is the ratio of the No. of subscribers (per 100 people) of Low & middle income in 2007 to that in 2010?
Offer a very short reply. 1.12. What is the ratio of the No. of subscribers (per 100 people) in Sierra Leone in 2007 to that in 2010?
Your answer should be very brief. 2.3. What is the ratio of the No. of subscribers (per 100 people) in Low & middle income in 2007 to that in 2011?
Provide a succinct answer. 1.16. What is the ratio of the No. of subscribers (per 100 people) in Middle East & North Africa (all income levels) in 2007 to that in 2011?
Provide a short and direct response. 0.99. What is the ratio of the No. of subscribers (per 100 people) of Sierra Leone in 2007 to that in 2011?
Your answer should be very brief. 2.05. What is the ratio of the No. of subscribers (per 100 people) of Low & middle income in 2008 to that in 2009?
Your answer should be compact. 1.05. What is the ratio of the No. of subscribers (per 100 people) of Middle East & North Africa (all income levels) in 2008 to that in 2009?
Offer a very short reply. 1.01. What is the ratio of the No. of subscribers (per 100 people) in Sierra Leone in 2008 to that in 2009?
Your answer should be very brief. 0.98. What is the ratio of the No. of subscribers (per 100 people) of Low & middle income in 2008 to that in 2010?
Ensure brevity in your answer.  1.1. What is the ratio of the No. of subscribers (per 100 people) of Sierra Leone in 2008 to that in 2010?
Make the answer very short. 2.34. What is the ratio of the No. of subscribers (per 100 people) in Low & middle income in 2008 to that in 2011?
Offer a terse response. 1.14. What is the ratio of the No. of subscribers (per 100 people) in Sierra Leone in 2008 to that in 2011?
Offer a very short reply. 2.09. What is the ratio of the No. of subscribers (per 100 people) of Low & middle income in 2009 to that in 2010?
Your answer should be compact. 1.05. What is the ratio of the No. of subscribers (per 100 people) in Middle East & North Africa (all income levels) in 2009 to that in 2010?
Make the answer very short. 1.02. What is the ratio of the No. of subscribers (per 100 people) in Sierra Leone in 2009 to that in 2010?
Offer a terse response. 2.39. What is the ratio of the No. of subscribers (per 100 people) in Low & middle income in 2009 to that in 2011?
Give a very brief answer. 1.09. What is the ratio of the No. of subscribers (per 100 people) in Middle East & North Africa (all income levels) in 2009 to that in 2011?
Offer a terse response. 1. What is the ratio of the No. of subscribers (per 100 people) in Sierra Leone in 2009 to that in 2011?
Make the answer very short. 2.13. What is the ratio of the No. of subscribers (per 100 people) of Low & middle income in 2010 to that in 2011?
Provide a succinct answer. 1.04. What is the ratio of the No. of subscribers (per 100 people) in Middle East & North Africa (all income levels) in 2010 to that in 2011?
Your answer should be compact. 0.99. What is the ratio of the No. of subscribers (per 100 people) of Sierra Leone in 2010 to that in 2011?
Make the answer very short. 0.89. What is the difference between the highest and the second highest No. of subscribers (per 100 people) in Low & middle income?
Provide a short and direct response. 0.03. What is the difference between the highest and the second highest No. of subscribers (per 100 people) in Middle East & North Africa (all income levels)?
Provide a short and direct response. 0.15. What is the difference between the highest and the second highest No. of subscribers (per 100 people) of Sierra Leone?
Offer a very short reply. 0.01. What is the difference between the highest and the lowest No. of subscribers (per 100 people) of Low & middle income?
Keep it short and to the point. 1.77. What is the difference between the highest and the lowest No. of subscribers (per 100 people) in Middle East & North Africa (all income levels)?
Your answer should be very brief. 3.23. What is the difference between the highest and the lowest No. of subscribers (per 100 people) of Sierra Leone?
Keep it short and to the point. 0.34. 